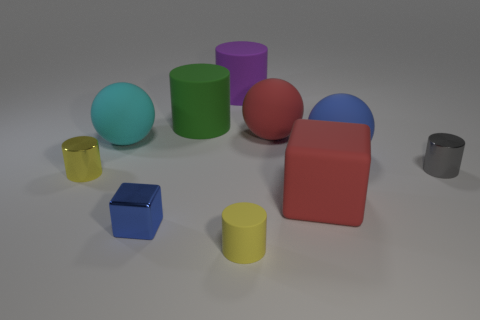What is the size of the cube on the left side of the tiny cylinder that is in front of the yellow metallic cylinder left of the big rubber cube?
Your answer should be very brief. Small. Are there more big objects than large purple matte cylinders?
Offer a very short reply. Yes. Is the material of the tiny yellow object that is right of the big purple cylinder the same as the blue cube?
Ensure brevity in your answer.  No. Is the number of large cubes less than the number of blue cylinders?
Offer a terse response. No. There is a yellow thing right of the yellow cylinder that is left of the tiny blue thing; is there a tiny matte thing in front of it?
Provide a short and direct response. No. Does the large red matte object that is behind the big cyan thing have the same shape as the big purple matte object?
Offer a very short reply. No. Is the number of large green objects in front of the green matte thing greater than the number of small yellow spheres?
Offer a terse response. No. There is a big matte ball that is behind the cyan thing; is its color the same as the small rubber object?
Make the answer very short. No. Is there any other thing of the same color as the tiny rubber object?
Offer a terse response. Yes. The big matte ball that is to the left of the matte cylinder in front of the metallic cylinder on the left side of the large blue thing is what color?
Provide a short and direct response. Cyan. 